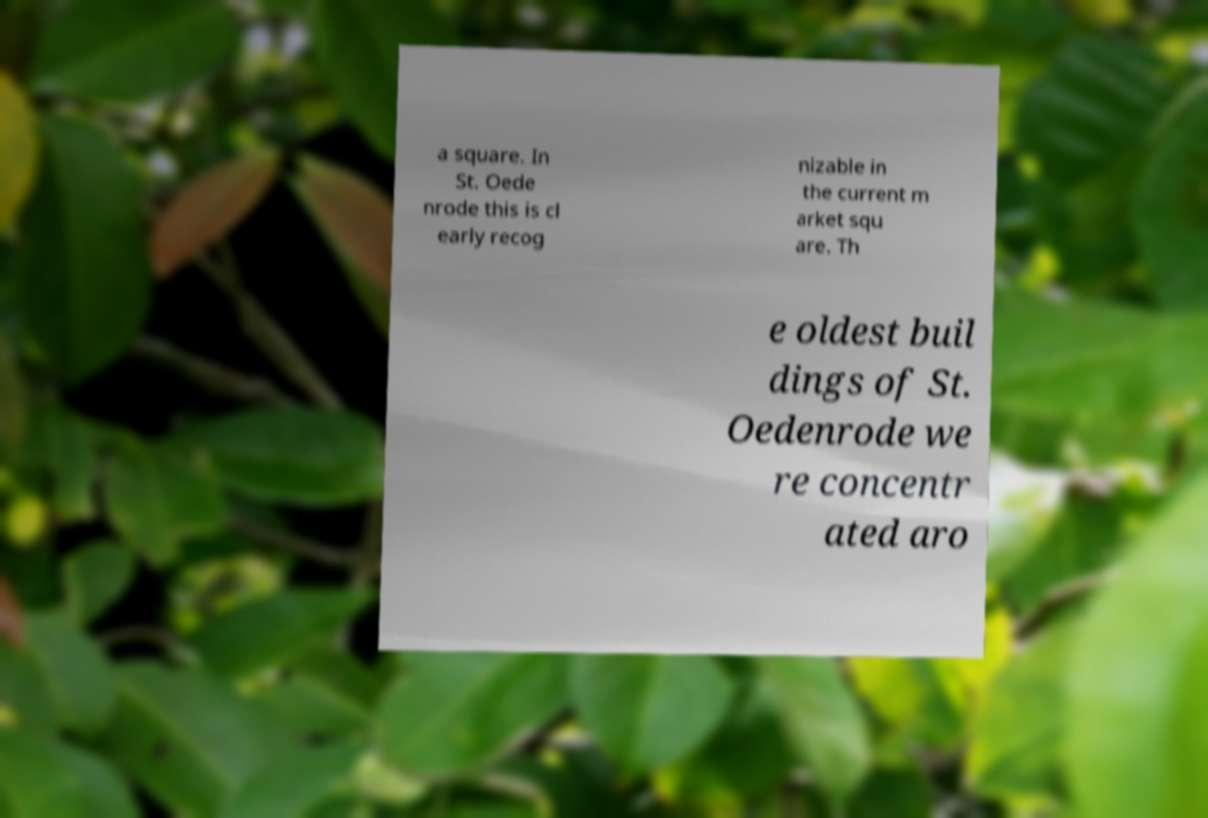What messages or text are displayed in this image? I need them in a readable, typed format. a square. In St. Oede nrode this is cl early recog nizable in the current m arket squ are. Th e oldest buil dings of St. Oedenrode we re concentr ated aro 